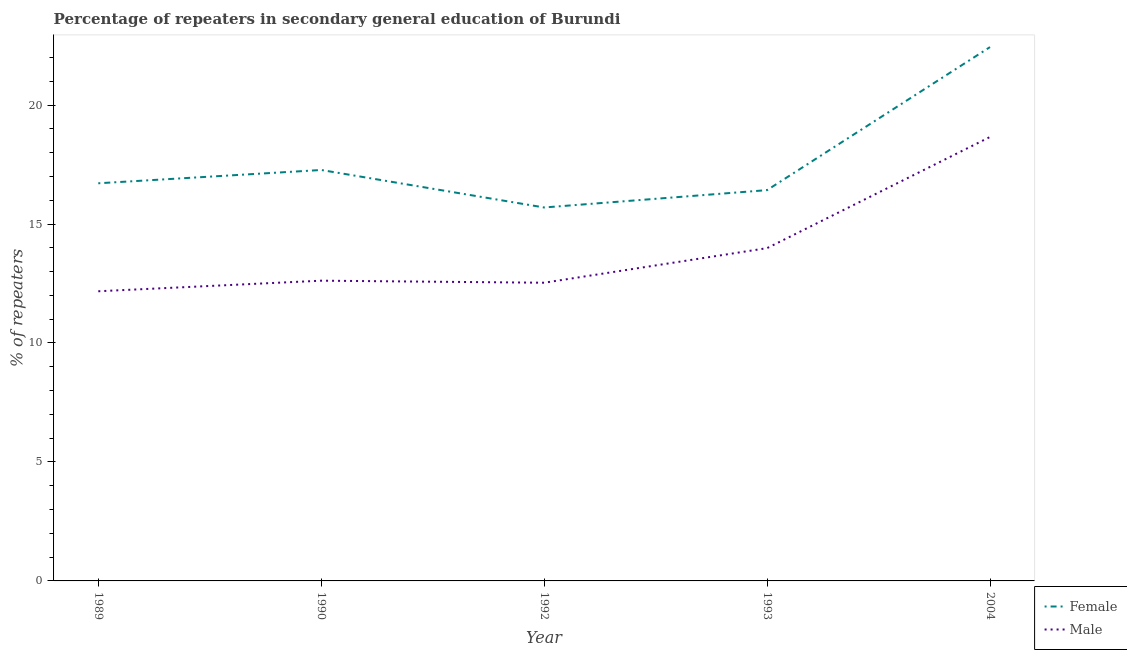How many different coloured lines are there?
Offer a very short reply. 2. Is the number of lines equal to the number of legend labels?
Provide a succinct answer. Yes. What is the percentage of female repeaters in 1993?
Offer a very short reply. 16.42. Across all years, what is the maximum percentage of male repeaters?
Offer a very short reply. 18.66. Across all years, what is the minimum percentage of female repeaters?
Make the answer very short. 15.7. In which year was the percentage of male repeaters minimum?
Provide a succinct answer. 1989. What is the total percentage of male repeaters in the graph?
Provide a succinct answer. 69.97. What is the difference between the percentage of male repeaters in 1989 and that in 1990?
Your answer should be very brief. -0.44. What is the difference between the percentage of female repeaters in 2004 and the percentage of male repeaters in 1993?
Your answer should be very brief. 8.45. What is the average percentage of female repeaters per year?
Your answer should be very brief. 17.71. In the year 1989, what is the difference between the percentage of male repeaters and percentage of female repeaters?
Your response must be concise. -4.54. What is the ratio of the percentage of female repeaters in 1993 to that in 2004?
Provide a short and direct response. 0.73. What is the difference between the highest and the second highest percentage of male repeaters?
Offer a terse response. 4.67. What is the difference between the highest and the lowest percentage of male repeaters?
Offer a terse response. 6.48. In how many years, is the percentage of female repeaters greater than the average percentage of female repeaters taken over all years?
Your response must be concise. 1. Is the sum of the percentage of male repeaters in 1989 and 1993 greater than the maximum percentage of female repeaters across all years?
Ensure brevity in your answer.  Yes. Does the percentage of male repeaters monotonically increase over the years?
Your answer should be very brief. No. How many lines are there?
Your answer should be very brief. 2. What is the difference between two consecutive major ticks on the Y-axis?
Your response must be concise. 5. Are the values on the major ticks of Y-axis written in scientific E-notation?
Keep it short and to the point. No. What is the title of the graph?
Make the answer very short. Percentage of repeaters in secondary general education of Burundi. Does "Number of departures" appear as one of the legend labels in the graph?
Offer a very short reply. No. What is the label or title of the X-axis?
Ensure brevity in your answer.  Year. What is the label or title of the Y-axis?
Your answer should be compact. % of repeaters. What is the % of repeaters in Female in 1989?
Provide a short and direct response. 16.71. What is the % of repeaters of Male in 1989?
Your answer should be very brief. 12.17. What is the % of repeaters in Female in 1990?
Keep it short and to the point. 17.27. What is the % of repeaters in Male in 1990?
Make the answer very short. 12.62. What is the % of repeaters of Female in 1992?
Ensure brevity in your answer.  15.7. What is the % of repeaters of Male in 1992?
Your answer should be compact. 12.53. What is the % of repeaters in Female in 1993?
Keep it short and to the point. 16.42. What is the % of repeaters of Male in 1993?
Offer a terse response. 13.99. What is the % of repeaters of Female in 2004?
Make the answer very short. 22.44. What is the % of repeaters in Male in 2004?
Ensure brevity in your answer.  18.66. Across all years, what is the maximum % of repeaters in Female?
Keep it short and to the point. 22.44. Across all years, what is the maximum % of repeaters in Male?
Offer a very short reply. 18.66. Across all years, what is the minimum % of repeaters of Female?
Offer a very short reply. 15.7. Across all years, what is the minimum % of repeaters of Male?
Keep it short and to the point. 12.17. What is the total % of repeaters of Female in the graph?
Your response must be concise. 88.54. What is the total % of repeaters in Male in the graph?
Your answer should be compact. 69.97. What is the difference between the % of repeaters in Female in 1989 and that in 1990?
Your response must be concise. -0.56. What is the difference between the % of repeaters of Male in 1989 and that in 1990?
Your answer should be compact. -0.44. What is the difference between the % of repeaters in Female in 1989 and that in 1992?
Make the answer very short. 1.02. What is the difference between the % of repeaters in Male in 1989 and that in 1992?
Your response must be concise. -0.36. What is the difference between the % of repeaters in Female in 1989 and that in 1993?
Your response must be concise. 0.29. What is the difference between the % of repeaters of Male in 1989 and that in 1993?
Provide a succinct answer. -1.81. What is the difference between the % of repeaters in Female in 1989 and that in 2004?
Provide a short and direct response. -5.72. What is the difference between the % of repeaters in Male in 1989 and that in 2004?
Your answer should be very brief. -6.48. What is the difference between the % of repeaters of Female in 1990 and that in 1992?
Provide a short and direct response. 1.58. What is the difference between the % of repeaters of Male in 1990 and that in 1992?
Make the answer very short. 0.09. What is the difference between the % of repeaters of Female in 1990 and that in 1993?
Your answer should be compact. 0.85. What is the difference between the % of repeaters in Male in 1990 and that in 1993?
Make the answer very short. -1.37. What is the difference between the % of repeaters in Female in 1990 and that in 2004?
Make the answer very short. -5.17. What is the difference between the % of repeaters in Male in 1990 and that in 2004?
Offer a very short reply. -6.04. What is the difference between the % of repeaters in Female in 1992 and that in 1993?
Give a very brief answer. -0.73. What is the difference between the % of repeaters of Male in 1992 and that in 1993?
Keep it short and to the point. -1.45. What is the difference between the % of repeaters of Female in 1992 and that in 2004?
Make the answer very short. -6.74. What is the difference between the % of repeaters of Male in 1992 and that in 2004?
Provide a succinct answer. -6.13. What is the difference between the % of repeaters of Female in 1993 and that in 2004?
Ensure brevity in your answer.  -6.01. What is the difference between the % of repeaters in Male in 1993 and that in 2004?
Give a very brief answer. -4.67. What is the difference between the % of repeaters in Female in 1989 and the % of repeaters in Male in 1990?
Keep it short and to the point. 4.09. What is the difference between the % of repeaters in Female in 1989 and the % of repeaters in Male in 1992?
Provide a succinct answer. 4.18. What is the difference between the % of repeaters of Female in 1989 and the % of repeaters of Male in 1993?
Offer a very short reply. 2.73. What is the difference between the % of repeaters in Female in 1989 and the % of repeaters in Male in 2004?
Your answer should be compact. -1.95. What is the difference between the % of repeaters of Female in 1990 and the % of repeaters of Male in 1992?
Provide a succinct answer. 4.74. What is the difference between the % of repeaters of Female in 1990 and the % of repeaters of Male in 1993?
Offer a terse response. 3.28. What is the difference between the % of repeaters of Female in 1990 and the % of repeaters of Male in 2004?
Offer a very short reply. -1.39. What is the difference between the % of repeaters in Female in 1992 and the % of repeaters in Male in 1993?
Provide a succinct answer. 1.71. What is the difference between the % of repeaters in Female in 1992 and the % of repeaters in Male in 2004?
Your answer should be very brief. -2.96. What is the difference between the % of repeaters of Female in 1993 and the % of repeaters of Male in 2004?
Make the answer very short. -2.23. What is the average % of repeaters in Female per year?
Ensure brevity in your answer.  17.71. What is the average % of repeaters of Male per year?
Provide a succinct answer. 13.99. In the year 1989, what is the difference between the % of repeaters in Female and % of repeaters in Male?
Keep it short and to the point. 4.54. In the year 1990, what is the difference between the % of repeaters of Female and % of repeaters of Male?
Make the answer very short. 4.65. In the year 1992, what is the difference between the % of repeaters in Female and % of repeaters in Male?
Provide a succinct answer. 3.16. In the year 1993, what is the difference between the % of repeaters of Female and % of repeaters of Male?
Provide a succinct answer. 2.44. In the year 2004, what is the difference between the % of repeaters in Female and % of repeaters in Male?
Your response must be concise. 3.78. What is the ratio of the % of repeaters in Female in 1989 to that in 1990?
Offer a terse response. 0.97. What is the ratio of the % of repeaters of Male in 1989 to that in 1990?
Provide a succinct answer. 0.96. What is the ratio of the % of repeaters of Female in 1989 to that in 1992?
Make the answer very short. 1.06. What is the ratio of the % of repeaters of Male in 1989 to that in 1992?
Provide a short and direct response. 0.97. What is the ratio of the % of repeaters of Female in 1989 to that in 1993?
Give a very brief answer. 1.02. What is the ratio of the % of repeaters in Male in 1989 to that in 1993?
Make the answer very short. 0.87. What is the ratio of the % of repeaters of Female in 1989 to that in 2004?
Provide a short and direct response. 0.74. What is the ratio of the % of repeaters of Male in 1989 to that in 2004?
Give a very brief answer. 0.65. What is the ratio of the % of repeaters in Female in 1990 to that in 1992?
Give a very brief answer. 1.1. What is the ratio of the % of repeaters in Male in 1990 to that in 1992?
Your response must be concise. 1.01. What is the ratio of the % of repeaters in Female in 1990 to that in 1993?
Make the answer very short. 1.05. What is the ratio of the % of repeaters in Male in 1990 to that in 1993?
Keep it short and to the point. 0.9. What is the ratio of the % of repeaters in Female in 1990 to that in 2004?
Give a very brief answer. 0.77. What is the ratio of the % of repeaters of Male in 1990 to that in 2004?
Ensure brevity in your answer.  0.68. What is the ratio of the % of repeaters of Female in 1992 to that in 1993?
Your answer should be compact. 0.96. What is the ratio of the % of repeaters in Male in 1992 to that in 1993?
Your response must be concise. 0.9. What is the ratio of the % of repeaters of Female in 1992 to that in 2004?
Keep it short and to the point. 0.7. What is the ratio of the % of repeaters of Male in 1992 to that in 2004?
Give a very brief answer. 0.67. What is the ratio of the % of repeaters in Female in 1993 to that in 2004?
Ensure brevity in your answer.  0.73. What is the ratio of the % of repeaters of Male in 1993 to that in 2004?
Keep it short and to the point. 0.75. What is the difference between the highest and the second highest % of repeaters in Female?
Your answer should be very brief. 5.17. What is the difference between the highest and the second highest % of repeaters in Male?
Make the answer very short. 4.67. What is the difference between the highest and the lowest % of repeaters of Female?
Keep it short and to the point. 6.74. What is the difference between the highest and the lowest % of repeaters in Male?
Offer a terse response. 6.48. 